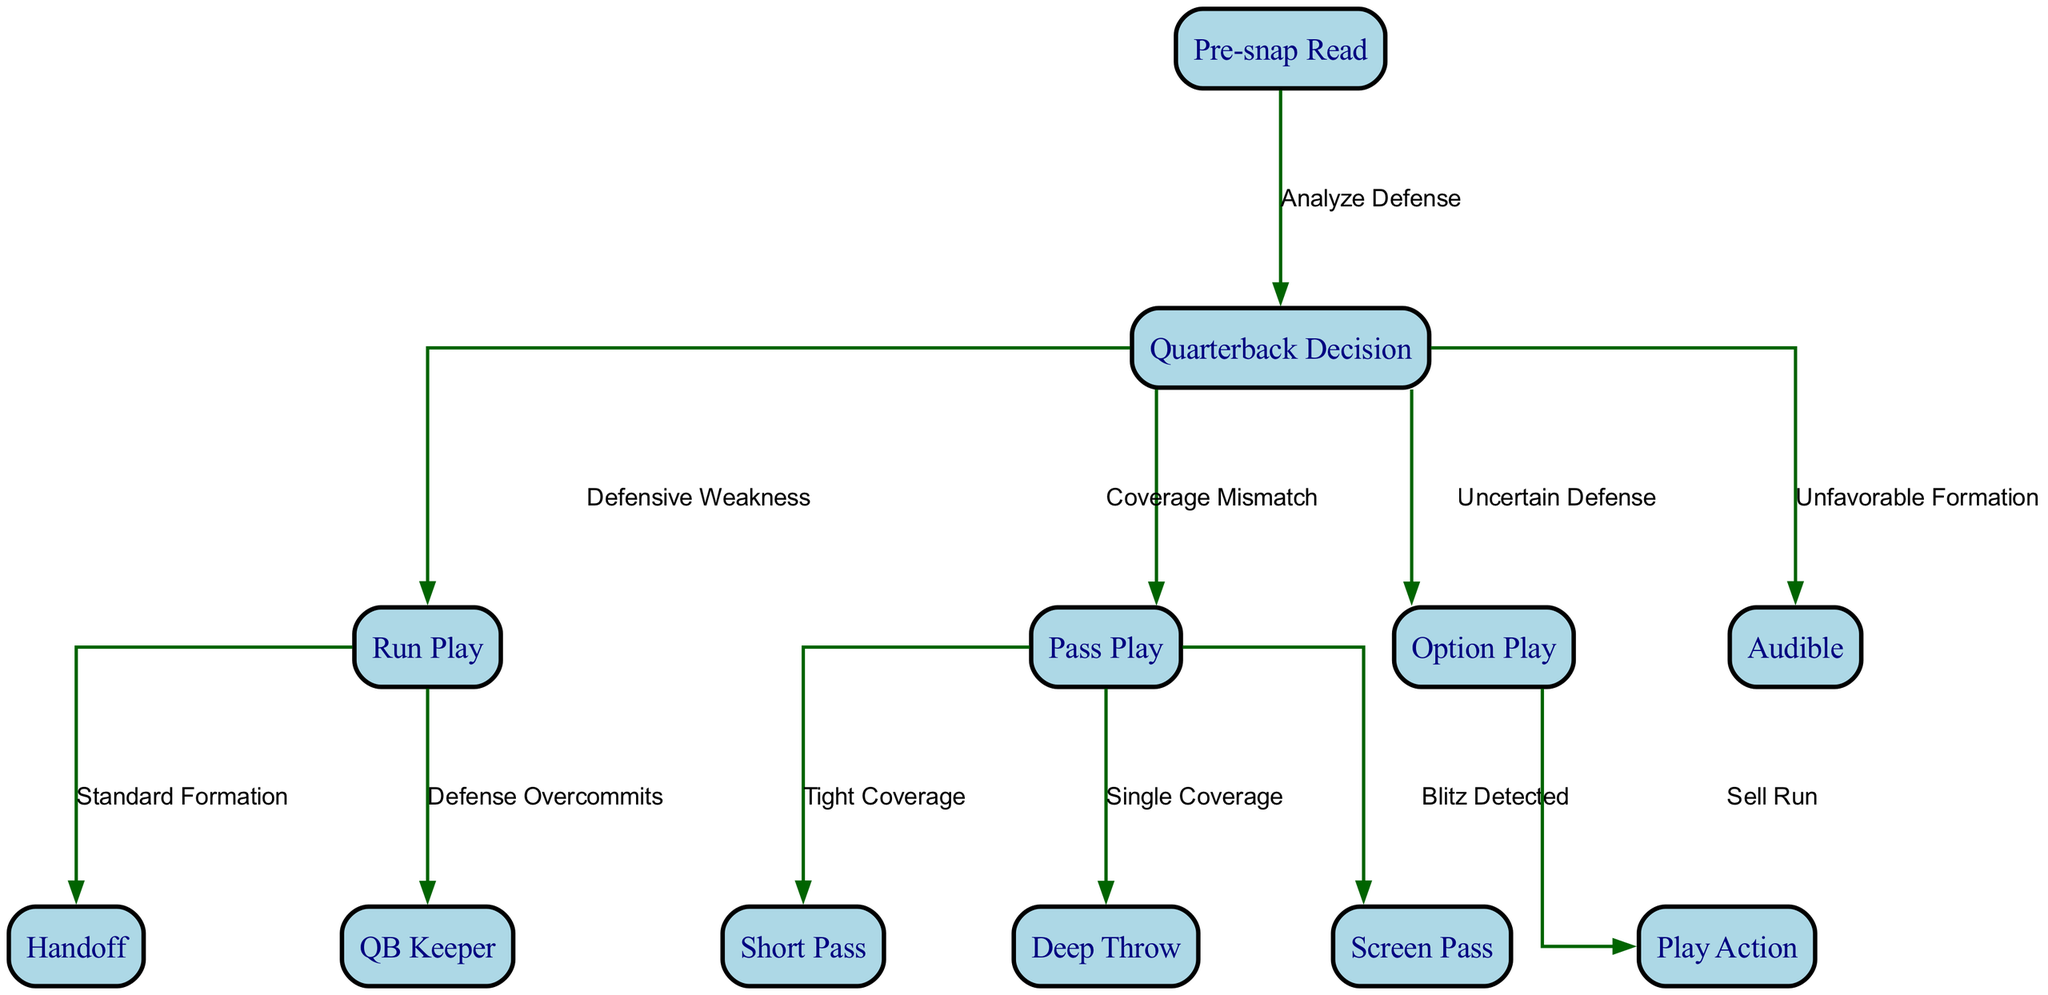What is the starting point of the flowchart? The flowchart begins with the "Pre-snap Read" node, which is the initial step in analyzing the defense before making a quarterback decision.
Answer: Pre-snap Read How many nodes are there in the diagram? Counting the nodes listed, there are a total of 11 distinct nodes that represent different stages or actions in the game strategy flowchart.
Answer: 11 What type of decision leads to a "Run Play"? According to the diagram, a "Run Play" is chosen as a result of identifying a "Defensive Weakness" during the "Quarterback Decision" phase.
Answer: Defensive Weakness Which play is triggered by "Tight Coverage"? The diagram indicates that when "Tight Coverage" is detected during a "Pass Play," it leads to executing a "Short Pass."
Answer: Short Pass How many edges are connected to the "Pass Play"? The "Pass Play" has three edges connected to it, denoting three different decision outcomes based on the defense's coverage.
Answer: 3 What happens when the defense overcommits? If the defense overcommits during a "Run Play," this action leads to the "QB Keeper," which allows the quarterback to retain the ball and run.
Answer: QB Keeper What decision leads to a "Screen Pass"? The diagram outlines that a "Screen Pass" is chosen when "Blitz Detected" is identified during the "Pass Play" phase.
Answer: Blitz Detected Which type of play follows "Uncertain Defense"? The flowchart indicates that in an "Uncertain Defense" scenario, the decision is made to perform an "Option Play."
Answer: Option Play What is the relationship between "Option Play" and "Play Action"? The diagram shows that "Play Action" is initiated as a subsequent decision derived from the "Option Play," specifically when the intent to sell the run is present.
Answer: Sell Run 